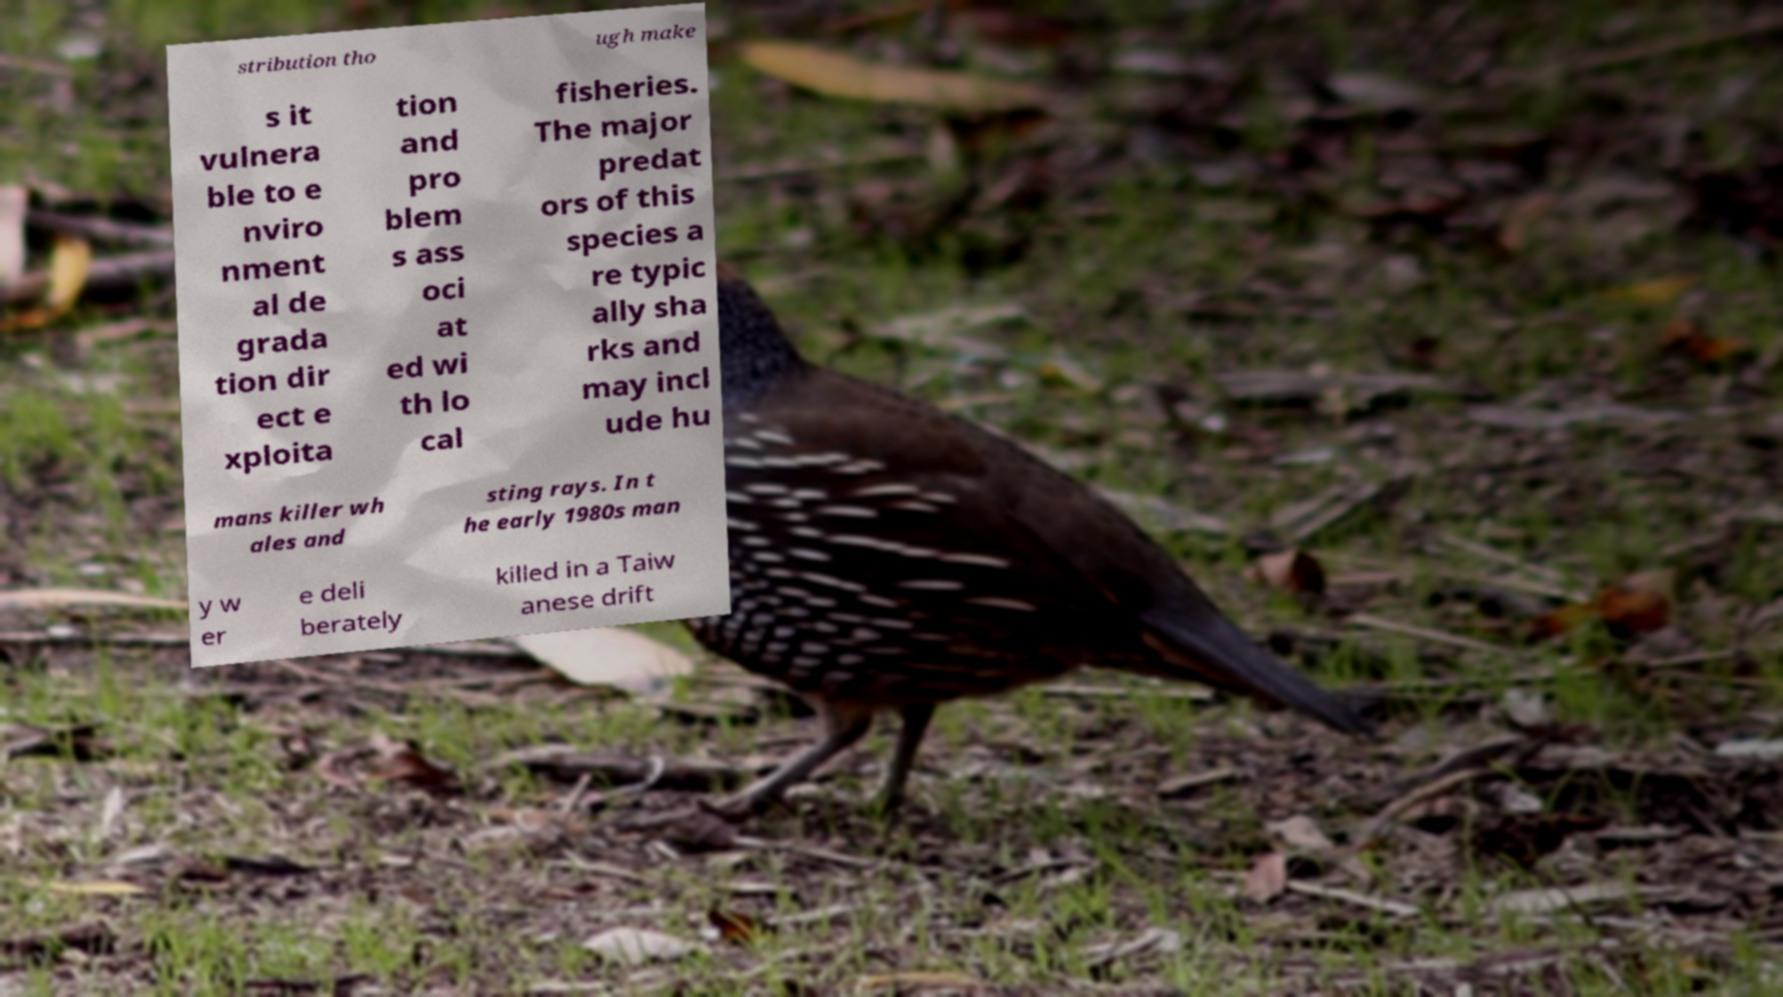Can you accurately transcribe the text from the provided image for me? stribution tho ugh make s it vulnera ble to e nviro nment al de grada tion dir ect e xploita tion and pro blem s ass oci at ed wi th lo cal fisheries. The major predat ors of this species a re typic ally sha rks and may incl ude hu mans killer wh ales and sting rays. In t he early 1980s man y w er e deli berately killed in a Taiw anese drift 